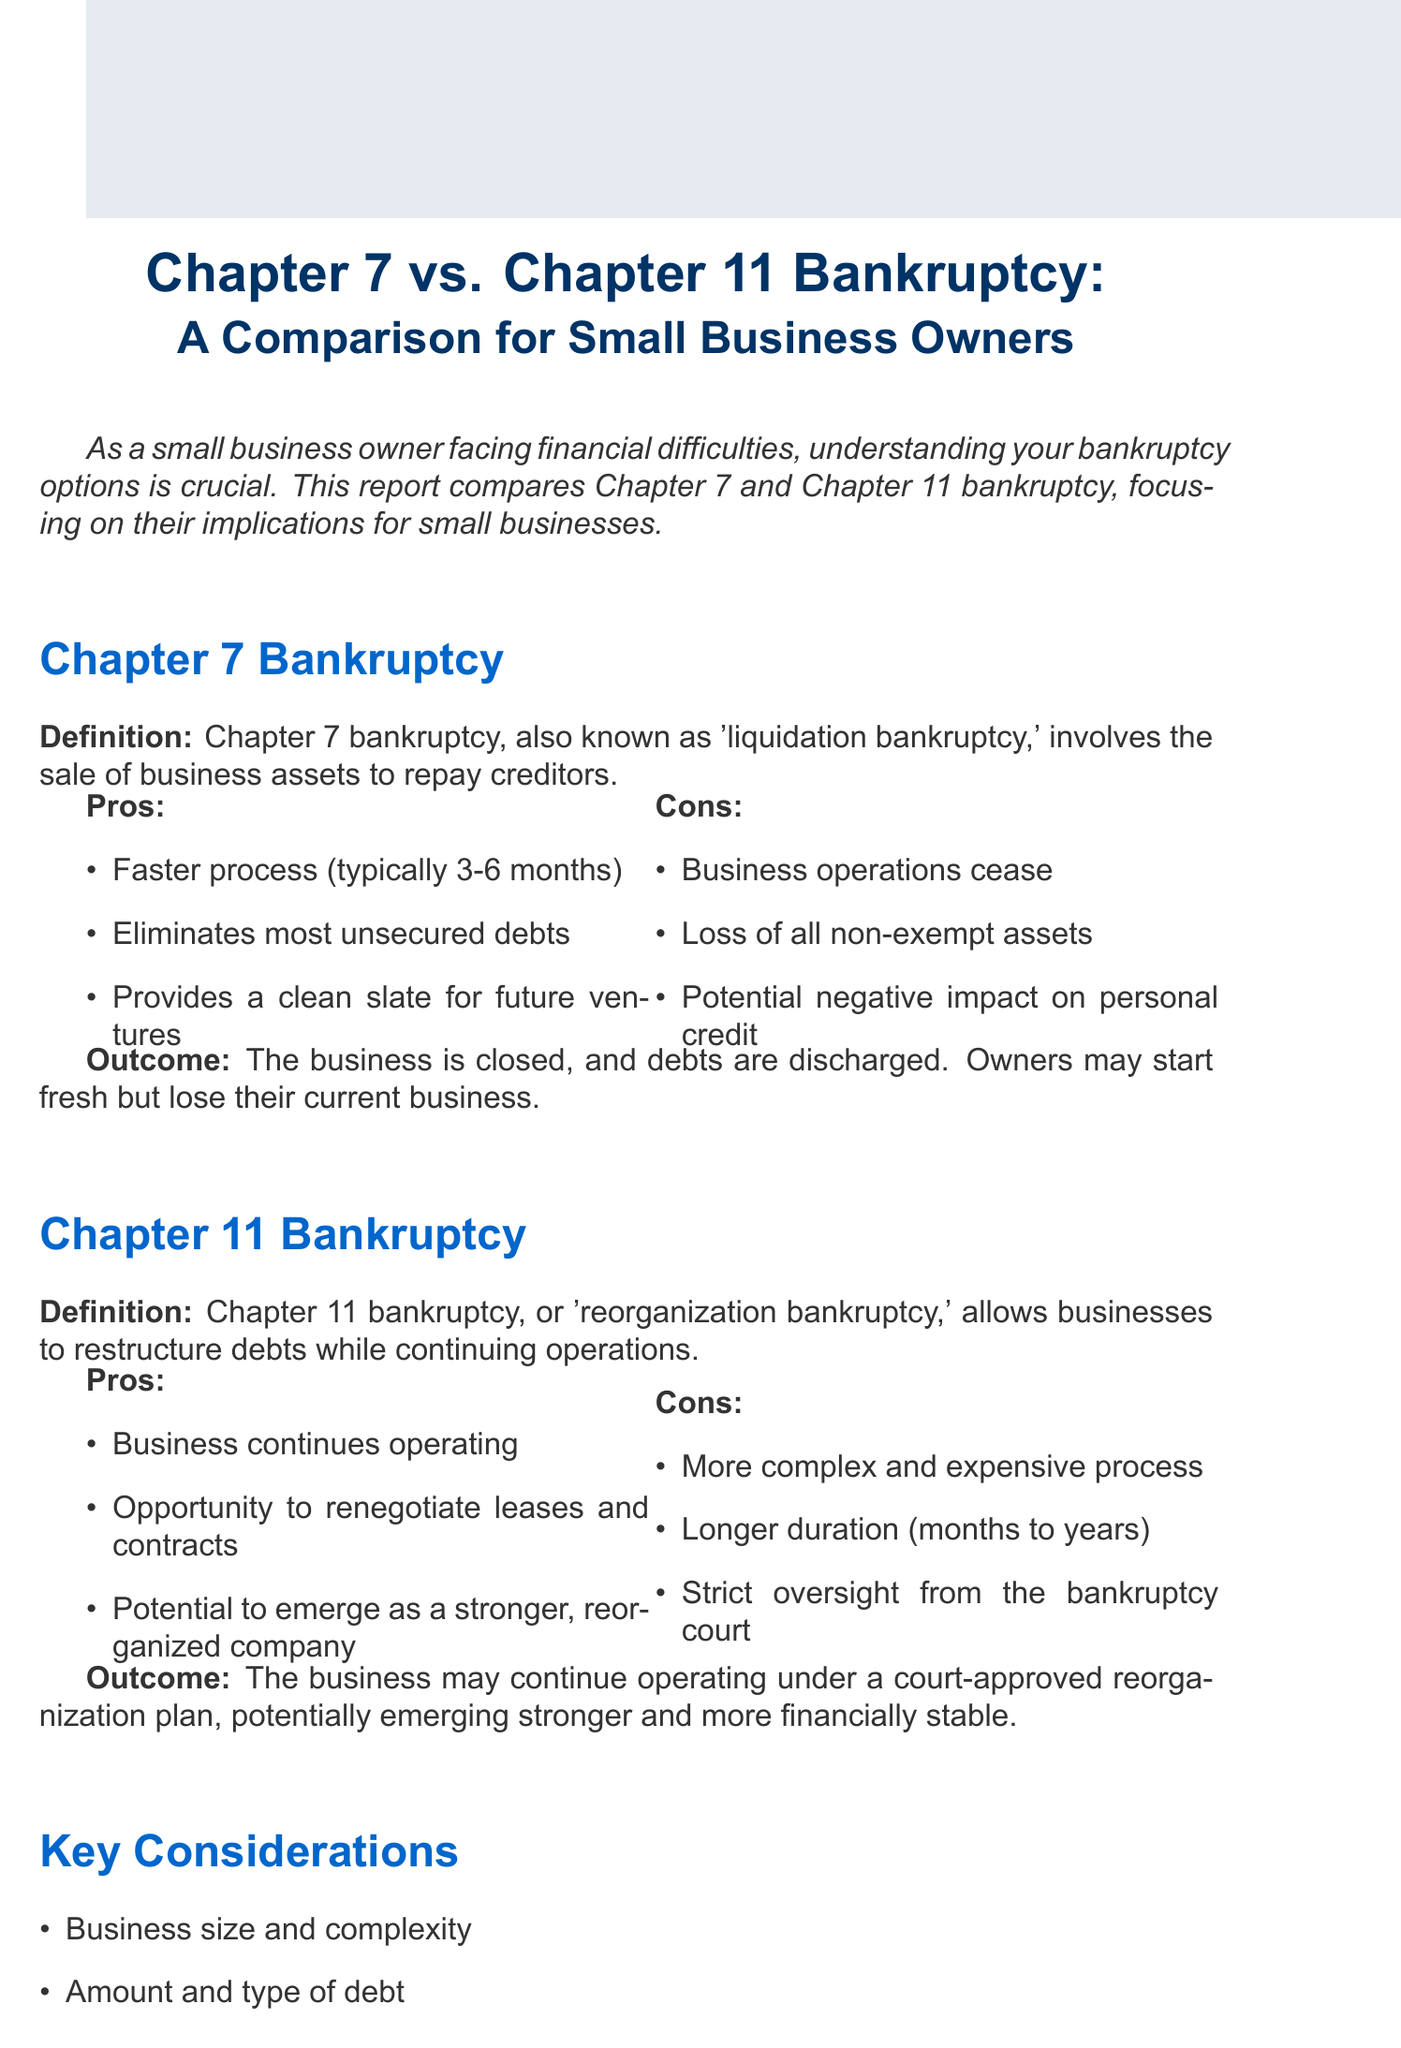What is Chapter 7 bankruptcy? Chapter 7 bankruptcy is defined as "liquidation bankruptcy," involving the sale of business assets to repay creditors.
Answer: liquidation bankruptcy What is a pro of Chapter 11 bankruptcy? A pro of Chapter 11 bankruptcy includes the ability for the business to continue operating.
Answer: Business continues operating What is the duration of the Chapter 7 process? The duration of the Chapter 7 process is typically 3-6 months.
Answer: 3-6 months What is a con of Chapter 7 bankruptcy? A con of Chapter 7 bankruptcy is the loss of all non-exempt assets.
Answer: Loss of all non-exempt assets What is one consideration before choosing a bankruptcy option? One consideration before choosing a bankruptcy option is the amount and type of debt.
Answer: Amount and type of debt What kind of oversight does Chapter 11 bankruptcy involve? Chapter 11 bankruptcy involves strict oversight from the bankruptcy court.
Answer: strict oversight How long can Chapter 11 bankruptcy take? The duration of Chapter 11 bankruptcy can range from months to years.
Answer: months to years Who should you consult for bankruptcy advice? For bankruptcy advice, you should consult with a bankruptcy attorney.
Answer: bankruptcy attorney 